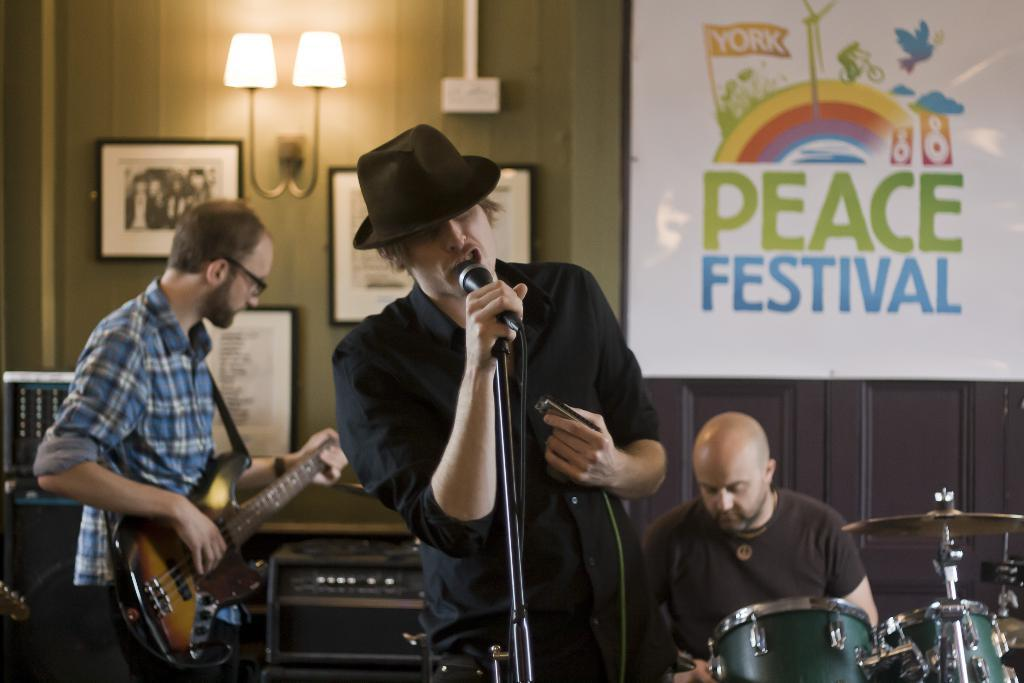What is the person in the image wearing? The person is wearing a black shirt in the image. What is the person doing in the image? The person is standing and singing in the image. What object is in front of the person? There is a microphone in front of the person. What are the two people behind the person doing? The two people behind the person are playing musical instruments. What type of soap is being used to clean the microphone in the image? There is no soap or cleaning activity depicted in the image; the focus is on the person singing and the two people playing musical instruments. 